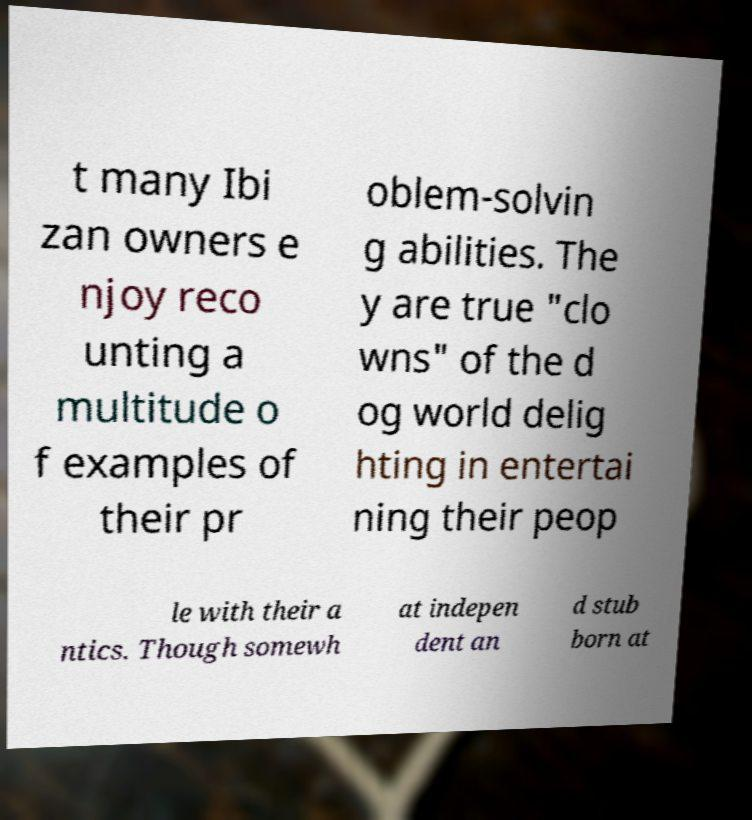Could you extract and type out the text from this image? t many Ibi zan owners e njoy reco unting a multitude o f examples of their pr oblem-solvin g abilities. The y are true "clo wns" of the d og world delig hting in entertai ning their peop le with their a ntics. Though somewh at indepen dent an d stub born at 